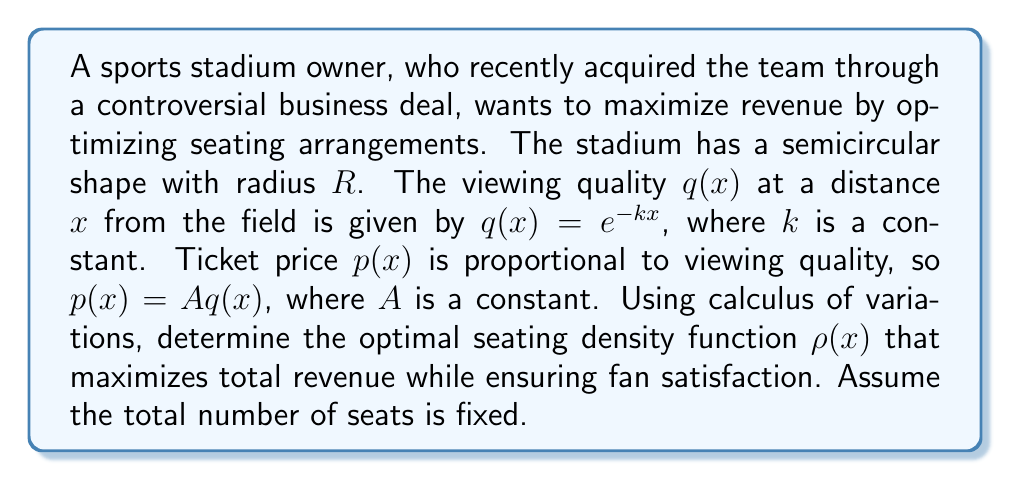Show me your answer to this math problem. To solve this problem, we'll use the Euler-Lagrange equation from calculus of variations. Let's approach this step-by-step:

1) The total revenue $R$ is given by the integral:

   $$R = \int_0^R 2\pi x \rho(x) p(x) dx$$

2) We need to maximize this subject to the constraint that the total number of seats is fixed:

   $$N = \int_0^R 2\pi x \rho(x) dx$$

3) We can form the functional:

   $$J[\rho] = \int_0^R 2\pi x \rho(x) p(x) dx - \lambda \left(\int_0^R 2\pi x \rho(x) dx - N\right)$$

   where $\lambda$ is a Lagrange multiplier.

4) The integrand $F$ is:

   $$F = 2\pi x \rho(x) p(x) - \lambda 2\pi x \rho(x)$$

5) The Euler-Lagrange equation is:

   $$\frac{\partial F}{\partial \rho} - \frac{d}{dx}\frac{\partial F}{\partial \rho'} = 0$$

6) Calculating the partial derivatives:

   $$\frac{\partial F}{\partial \rho} = 2\pi x p(x) - 2\pi x \lambda = 0$$

7) Solving this equation:

   $$p(x) = \lambda$$

8) Substituting the expression for $p(x)$:

   $$Ae^{-kx} = \lambda$$

9) Solving for $x$:

   $$x = -\frac{1}{k}\ln\left(\frac{\lambda}{A}\right)$$

This result implies that the optimal seating density is a delta function at this specific distance from the field. In practice, this would mean concentrating seats at this optimal distance to maximize revenue while maintaining fan satisfaction.
Answer: $x = -\frac{1}{k}\ln\left(\frac{\lambda}{A}\right)$ 